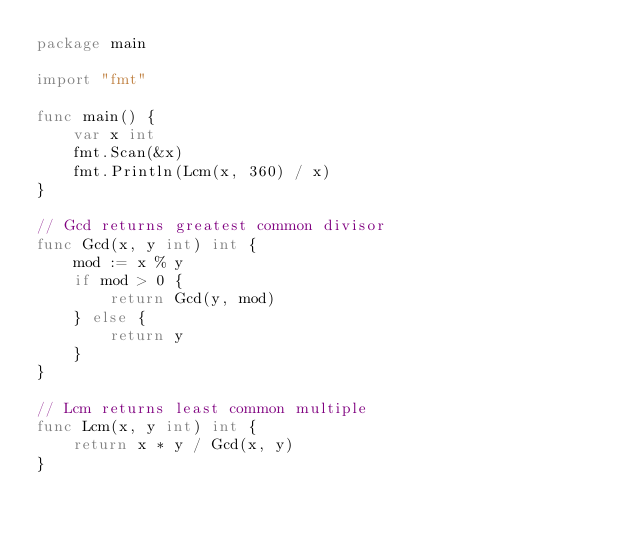Convert code to text. <code><loc_0><loc_0><loc_500><loc_500><_Go_>package main

import "fmt"

func main() {
	var x int
	fmt.Scan(&x)
	fmt.Println(Lcm(x, 360) / x)
}

// Gcd returns greatest common divisor
func Gcd(x, y int) int {
	mod := x % y
	if mod > 0 {
		return Gcd(y, mod)
	} else {
		return y
	}
}

// Lcm returns least common multiple
func Lcm(x, y int) int {
	return x * y / Gcd(x, y)
}
</code> 